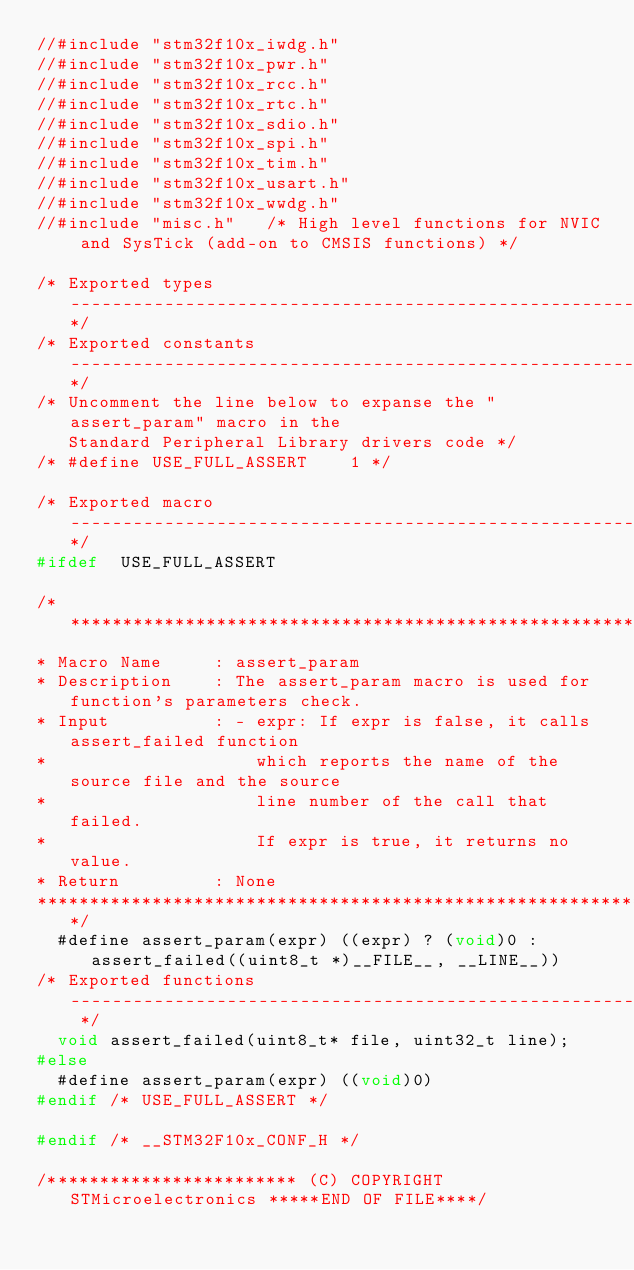<code> <loc_0><loc_0><loc_500><loc_500><_C_>//#include "stm32f10x_iwdg.h"
//#include "stm32f10x_pwr.h"
//#include "stm32f10x_rcc.h"
//#include "stm32f10x_rtc.h"
//#include "stm32f10x_sdio.h"
//#include "stm32f10x_spi.h"
//#include "stm32f10x_tim.h"
//#include "stm32f10x_usart.h"
//#include "stm32f10x_wwdg.h"
//#include "misc.h"   /* High level functions for NVIC and SysTick (add-on to CMSIS functions) */

/* Exported types ------------------------------------------------------------*/
/* Exported constants --------------------------------------------------------*/
/* Uncomment the line below to expanse the "assert_param" macro in the
   Standard Peripheral Library drivers code */
/* #define USE_FULL_ASSERT    1 */

/* Exported macro ------------------------------------------------------------*/
#ifdef  USE_FULL_ASSERT

/*******************************************************************************
* Macro Name     : assert_param
* Description    : The assert_param macro is used for function's parameters check.
* Input          : - expr: If expr is false, it calls assert_failed function
*                    which reports the name of the source file and the source
*                    line number of the call that failed.
*                    If expr is true, it returns no value.
* Return         : None
*******************************************************************************/
  #define assert_param(expr) ((expr) ? (void)0 : assert_failed((uint8_t *)__FILE__, __LINE__))
/* Exported functions ------------------------------------------------------- */
  void assert_failed(uint8_t* file, uint32_t line);
#else
  #define assert_param(expr) ((void)0)
#endif /* USE_FULL_ASSERT */

#endif /* __STM32F10x_CONF_H */

/************************ (C) COPYRIGHT STMicroelectronics *****END OF FILE****/
</code> 